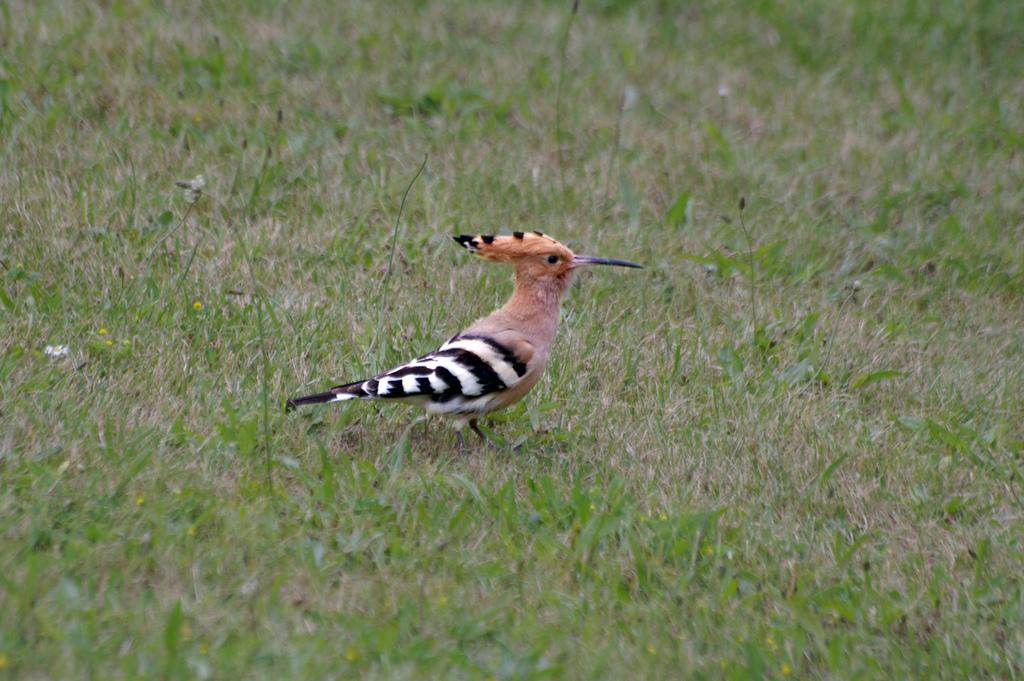What is the main subject in the middle of the image? There is a bird in the middle of the image. What type of environment can be seen in the background of the image? There is grass visible in the background of the image. What type of soup is being served in the image? There is no soup present in the image; it features a bird and grass in the background. 